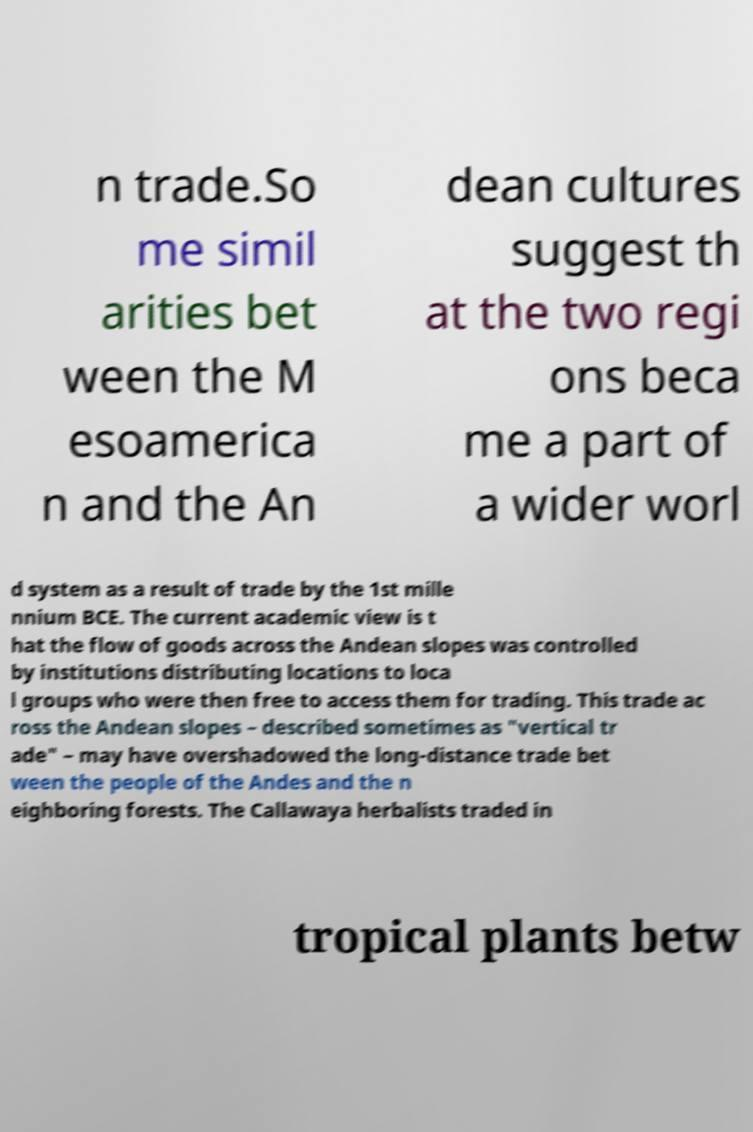Could you assist in decoding the text presented in this image and type it out clearly? n trade.So me simil arities bet ween the M esoamerica n and the An dean cultures suggest th at the two regi ons beca me a part of a wider worl d system as a result of trade by the 1st mille nnium BCE. The current academic view is t hat the flow of goods across the Andean slopes was controlled by institutions distributing locations to loca l groups who were then free to access them for trading. This trade ac ross the Andean slopes – described sometimes as "vertical tr ade" – may have overshadowed the long-distance trade bet ween the people of the Andes and the n eighboring forests. The Callawaya herbalists traded in tropical plants betw 